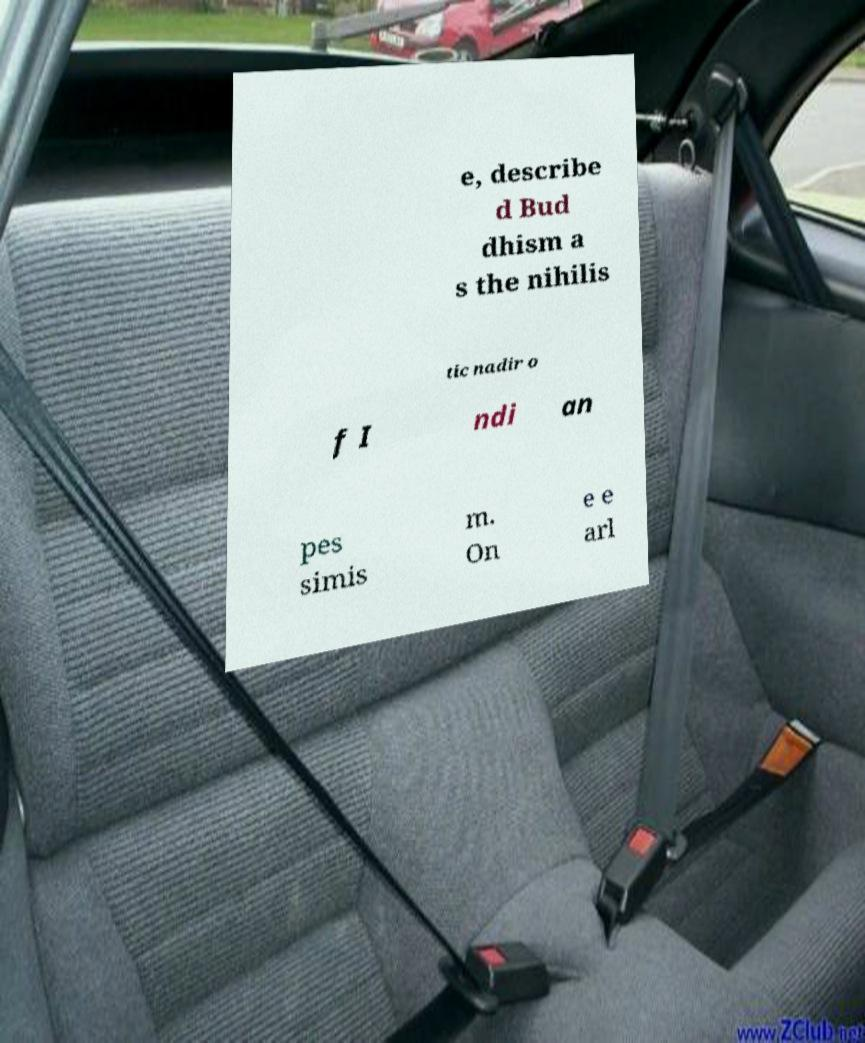For documentation purposes, I need the text within this image transcribed. Could you provide that? e, describe d Bud dhism a s the nihilis tic nadir o f I ndi an pes simis m. On e e arl 